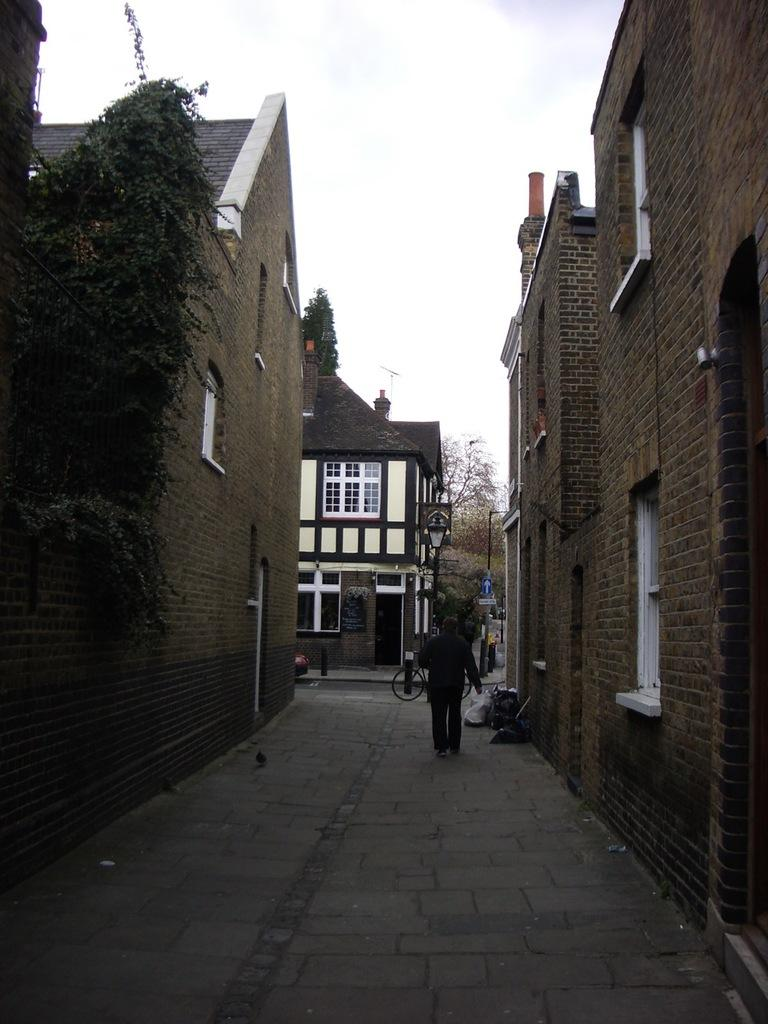What is the man in the image doing? The man in the image is walking on the road. What can be seen in the background of the image? The sky, clouds, trees, buildings, poles, a cycle, bags, and a few other objects are visible in the background of the image. Can you describe the weather in the image? The presence of clouds in the sky suggests that it might be partly cloudy. How many branches can be seen on the tree in the image? There is no tree present in the image; only the sky, clouds, trees, buildings, poles, a cycle, bags, and other objects are visible in the background. What type of balls are being used by the cats in the image? There are no cats or balls present in the image. 